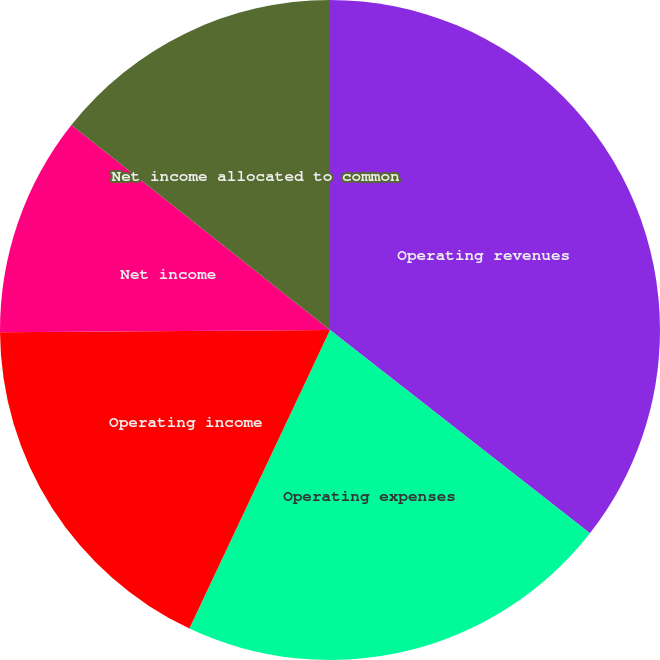Convert chart to OTSL. <chart><loc_0><loc_0><loc_500><loc_500><pie_chart><fcel>Operating revenues<fcel>Operating expenses<fcel>Operating income<fcel>Net income<fcel>Net income allocated to common<fcel>Diluted-net income per share<nl><fcel>35.56%<fcel>21.44%<fcel>17.89%<fcel>10.77%<fcel>14.33%<fcel>0.0%<nl></chart> 